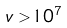<formula> <loc_0><loc_0><loc_500><loc_500>v > 1 0 ^ { 7 }</formula> 